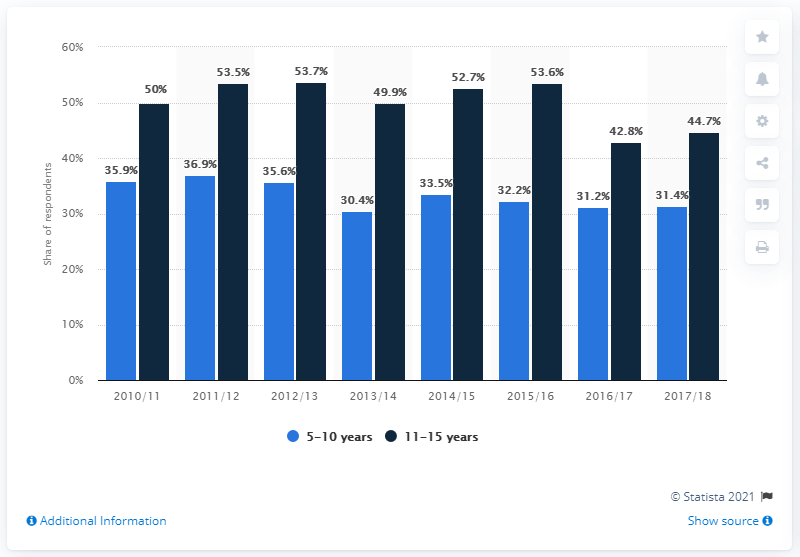Draw attention to some important aspects in this diagram. The sum of the children between 5-10 of the years 2010/11 and 2013/14 is 66.3. In the year 2011/12, there were the highest number of children between the ages of 5 and 10. 